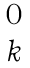Convert formula to latex. <formula><loc_0><loc_0><loc_500><loc_500>\begin{matrix} 0 \\ k \end{matrix}</formula> 